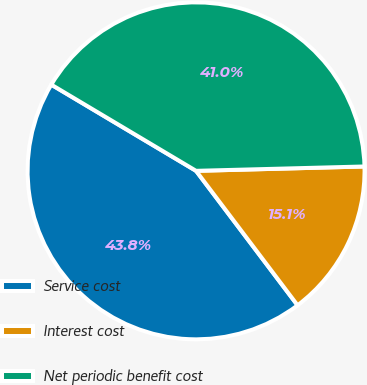Convert chart. <chart><loc_0><loc_0><loc_500><loc_500><pie_chart><fcel>Service cost<fcel>Interest cost<fcel>Net periodic benefit cost<nl><fcel>43.84%<fcel>15.12%<fcel>41.04%<nl></chart> 